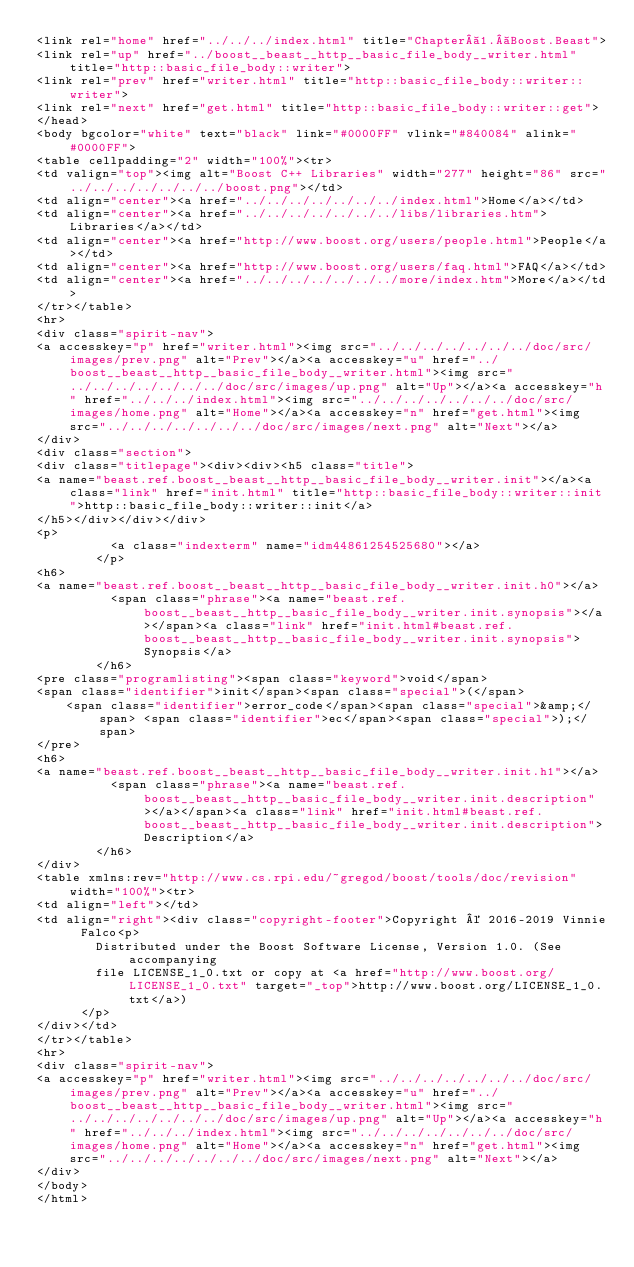Convert code to text. <code><loc_0><loc_0><loc_500><loc_500><_HTML_><link rel="home" href="../../../index.html" title="Chapter 1. Boost.Beast">
<link rel="up" href="../boost__beast__http__basic_file_body__writer.html" title="http::basic_file_body::writer">
<link rel="prev" href="writer.html" title="http::basic_file_body::writer::writer">
<link rel="next" href="get.html" title="http::basic_file_body::writer::get">
</head>
<body bgcolor="white" text="black" link="#0000FF" vlink="#840084" alink="#0000FF">
<table cellpadding="2" width="100%"><tr>
<td valign="top"><img alt="Boost C++ Libraries" width="277" height="86" src="../../../../../../../boost.png"></td>
<td align="center"><a href="../../../../../../../index.html">Home</a></td>
<td align="center"><a href="../../../../../../../libs/libraries.htm">Libraries</a></td>
<td align="center"><a href="http://www.boost.org/users/people.html">People</a></td>
<td align="center"><a href="http://www.boost.org/users/faq.html">FAQ</a></td>
<td align="center"><a href="../../../../../../../more/index.htm">More</a></td>
</tr></table>
<hr>
<div class="spirit-nav">
<a accesskey="p" href="writer.html"><img src="../../../../../../../doc/src/images/prev.png" alt="Prev"></a><a accesskey="u" href="../boost__beast__http__basic_file_body__writer.html"><img src="../../../../../../../doc/src/images/up.png" alt="Up"></a><a accesskey="h" href="../../../index.html"><img src="../../../../../../../doc/src/images/home.png" alt="Home"></a><a accesskey="n" href="get.html"><img src="../../../../../../../doc/src/images/next.png" alt="Next"></a>
</div>
<div class="section">
<div class="titlepage"><div><div><h5 class="title">
<a name="beast.ref.boost__beast__http__basic_file_body__writer.init"></a><a class="link" href="init.html" title="http::basic_file_body::writer::init">http::basic_file_body::writer::init</a>
</h5></div></div></div>
<p>
          <a class="indexterm" name="idm44861254525680"></a>
        </p>
<h6>
<a name="beast.ref.boost__beast__http__basic_file_body__writer.init.h0"></a>
          <span class="phrase"><a name="beast.ref.boost__beast__http__basic_file_body__writer.init.synopsis"></a></span><a class="link" href="init.html#beast.ref.boost__beast__http__basic_file_body__writer.init.synopsis">Synopsis</a>
        </h6>
<pre class="programlisting"><span class="keyword">void</span>
<span class="identifier">init</span><span class="special">(</span>
    <span class="identifier">error_code</span><span class="special">&amp;</span> <span class="identifier">ec</span><span class="special">);</span>
</pre>
<h6>
<a name="beast.ref.boost__beast__http__basic_file_body__writer.init.h1"></a>
          <span class="phrase"><a name="beast.ref.boost__beast__http__basic_file_body__writer.init.description"></a></span><a class="link" href="init.html#beast.ref.boost__beast__http__basic_file_body__writer.init.description">Description</a>
        </h6>
</div>
<table xmlns:rev="http://www.cs.rpi.edu/~gregod/boost/tools/doc/revision" width="100%"><tr>
<td align="left"></td>
<td align="right"><div class="copyright-footer">Copyright © 2016-2019 Vinnie
      Falco<p>
        Distributed under the Boost Software License, Version 1.0. (See accompanying
        file LICENSE_1_0.txt or copy at <a href="http://www.boost.org/LICENSE_1_0.txt" target="_top">http://www.boost.org/LICENSE_1_0.txt</a>)
      </p>
</div></td>
</tr></table>
<hr>
<div class="spirit-nav">
<a accesskey="p" href="writer.html"><img src="../../../../../../../doc/src/images/prev.png" alt="Prev"></a><a accesskey="u" href="../boost__beast__http__basic_file_body__writer.html"><img src="../../../../../../../doc/src/images/up.png" alt="Up"></a><a accesskey="h" href="../../../index.html"><img src="../../../../../../../doc/src/images/home.png" alt="Home"></a><a accesskey="n" href="get.html"><img src="../../../../../../../doc/src/images/next.png" alt="Next"></a>
</div>
</body>
</html>
</code> 